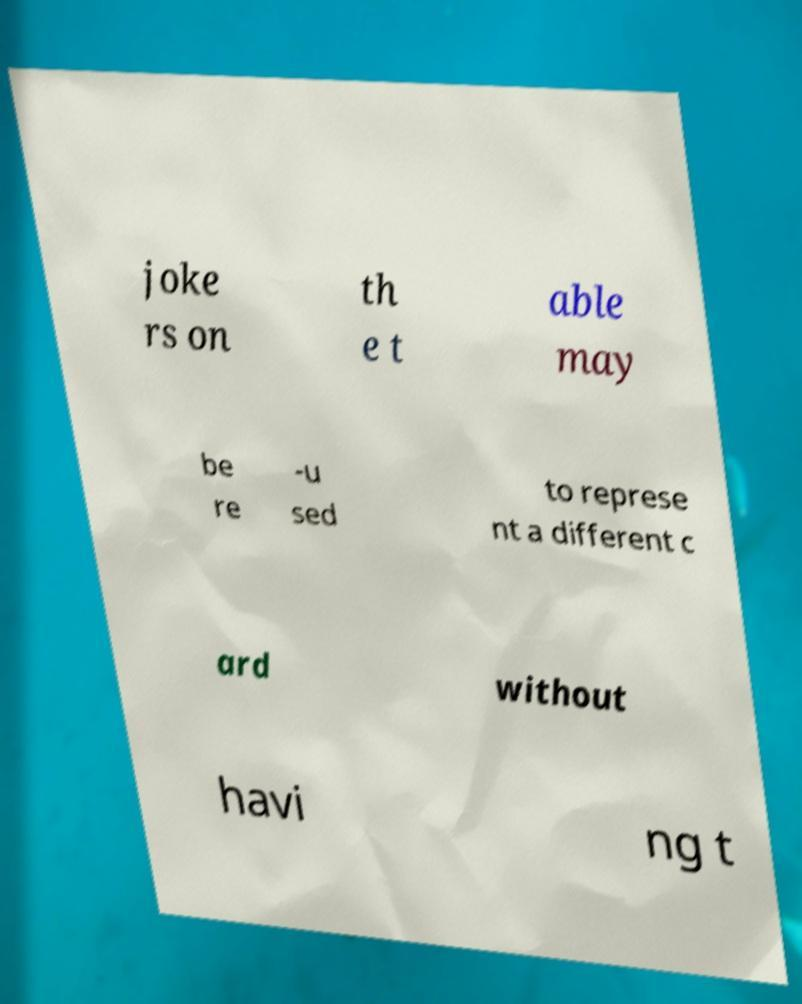There's text embedded in this image that I need extracted. Can you transcribe it verbatim? joke rs on th e t able may be re -u sed to represe nt a different c ard without havi ng t 